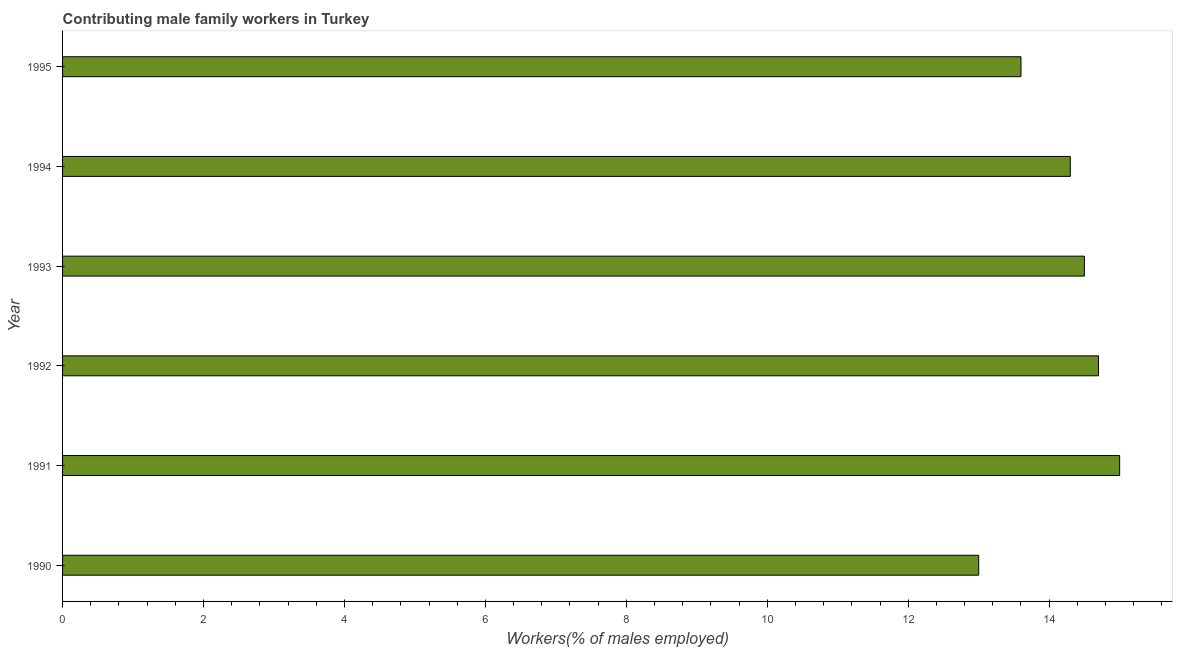Does the graph contain grids?
Your response must be concise. No. What is the title of the graph?
Your answer should be compact. Contributing male family workers in Turkey. What is the label or title of the X-axis?
Offer a very short reply. Workers(% of males employed). What is the label or title of the Y-axis?
Offer a terse response. Year. What is the contributing male family workers in 1994?
Offer a terse response. 14.3. Across all years, what is the maximum contributing male family workers?
Your answer should be compact. 15. Across all years, what is the minimum contributing male family workers?
Your answer should be very brief. 13. What is the sum of the contributing male family workers?
Ensure brevity in your answer.  85.1. What is the difference between the contributing male family workers in 1991 and 1993?
Give a very brief answer. 0.5. What is the average contributing male family workers per year?
Make the answer very short. 14.18. What is the median contributing male family workers?
Offer a very short reply. 14.4. Do a majority of the years between 1993 and 1994 (inclusive) have contributing male family workers greater than 8.8 %?
Give a very brief answer. Yes. What is the ratio of the contributing male family workers in 1993 to that in 1994?
Offer a very short reply. 1.01. Is the contributing male family workers in 1993 less than that in 1994?
Your response must be concise. No. In how many years, is the contributing male family workers greater than the average contributing male family workers taken over all years?
Provide a succinct answer. 4. How many years are there in the graph?
Your response must be concise. 6. What is the Workers(% of males employed) in 1991?
Ensure brevity in your answer.  15. What is the Workers(% of males employed) of 1992?
Offer a terse response. 14.7. What is the Workers(% of males employed) of 1994?
Your response must be concise. 14.3. What is the Workers(% of males employed) of 1995?
Provide a succinct answer. 13.6. What is the difference between the Workers(% of males employed) in 1990 and 1991?
Offer a terse response. -2. What is the difference between the Workers(% of males employed) in 1990 and 1995?
Offer a very short reply. -0.6. What is the difference between the Workers(% of males employed) in 1991 and 1992?
Offer a terse response. 0.3. What is the difference between the Workers(% of males employed) in 1991 and 1993?
Your response must be concise. 0.5. What is the difference between the Workers(% of males employed) in 1991 and 1995?
Provide a succinct answer. 1.4. What is the difference between the Workers(% of males employed) in 1992 and 1993?
Your answer should be very brief. 0.2. What is the difference between the Workers(% of males employed) in 1992 and 1994?
Ensure brevity in your answer.  0.4. What is the difference between the Workers(% of males employed) in 1993 and 1995?
Keep it short and to the point. 0.9. What is the ratio of the Workers(% of males employed) in 1990 to that in 1991?
Provide a short and direct response. 0.87. What is the ratio of the Workers(% of males employed) in 1990 to that in 1992?
Keep it short and to the point. 0.88. What is the ratio of the Workers(% of males employed) in 1990 to that in 1993?
Provide a succinct answer. 0.9. What is the ratio of the Workers(% of males employed) in 1990 to that in 1994?
Provide a short and direct response. 0.91. What is the ratio of the Workers(% of males employed) in 1990 to that in 1995?
Ensure brevity in your answer.  0.96. What is the ratio of the Workers(% of males employed) in 1991 to that in 1993?
Make the answer very short. 1.03. What is the ratio of the Workers(% of males employed) in 1991 to that in 1994?
Provide a short and direct response. 1.05. What is the ratio of the Workers(% of males employed) in 1991 to that in 1995?
Your answer should be compact. 1.1. What is the ratio of the Workers(% of males employed) in 1992 to that in 1993?
Your response must be concise. 1.01. What is the ratio of the Workers(% of males employed) in 1992 to that in 1994?
Offer a very short reply. 1.03. What is the ratio of the Workers(% of males employed) in 1992 to that in 1995?
Ensure brevity in your answer.  1.08. What is the ratio of the Workers(% of males employed) in 1993 to that in 1994?
Make the answer very short. 1.01. What is the ratio of the Workers(% of males employed) in 1993 to that in 1995?
Offer a terse response. 1.07. What is the ratio of the Workers(% of males employed) in 1994 to that in 1995?
Provide a short and direct response. 1.05. 